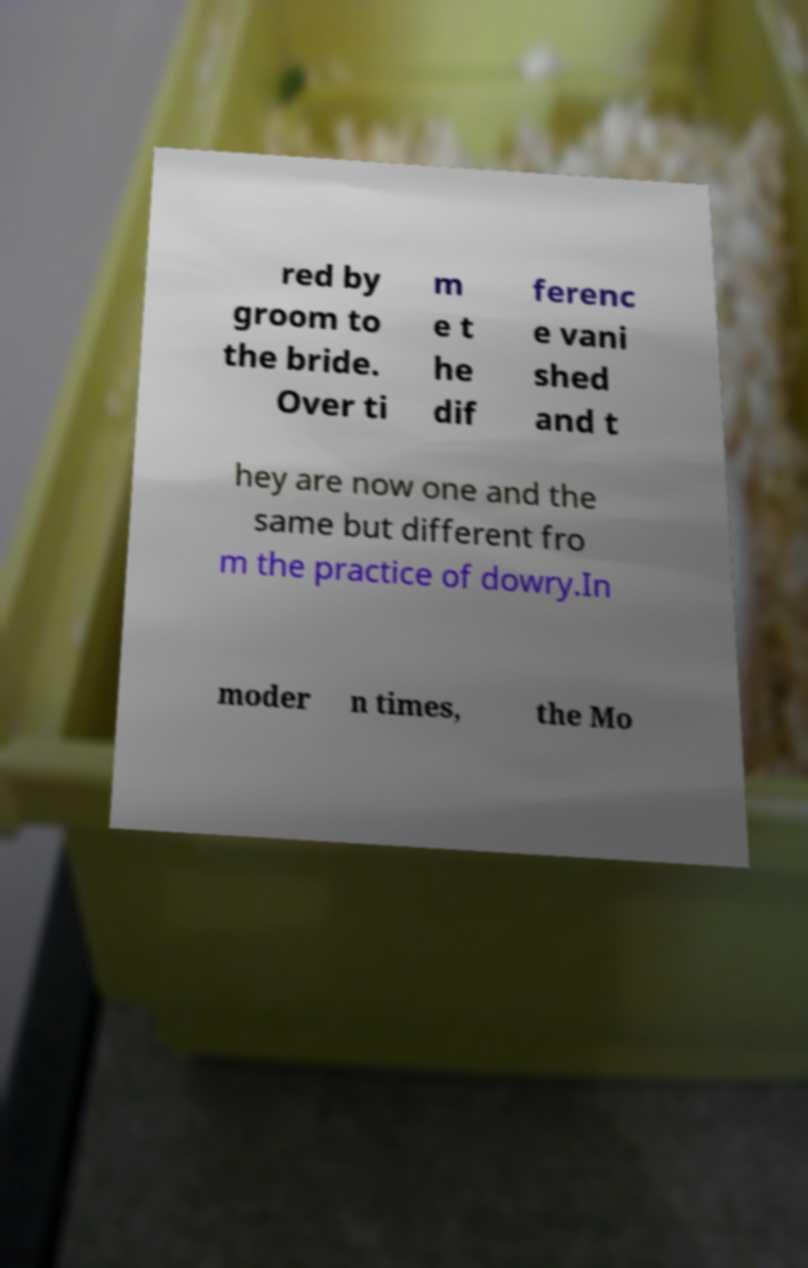Please read and relay the text visible in this image. What does it say? red by groom to the bride. Over ti m e t he dif ferenc e vani shed and t hey are now one and the same but different fro m the practice of dowry.In moder n times, the Mo 